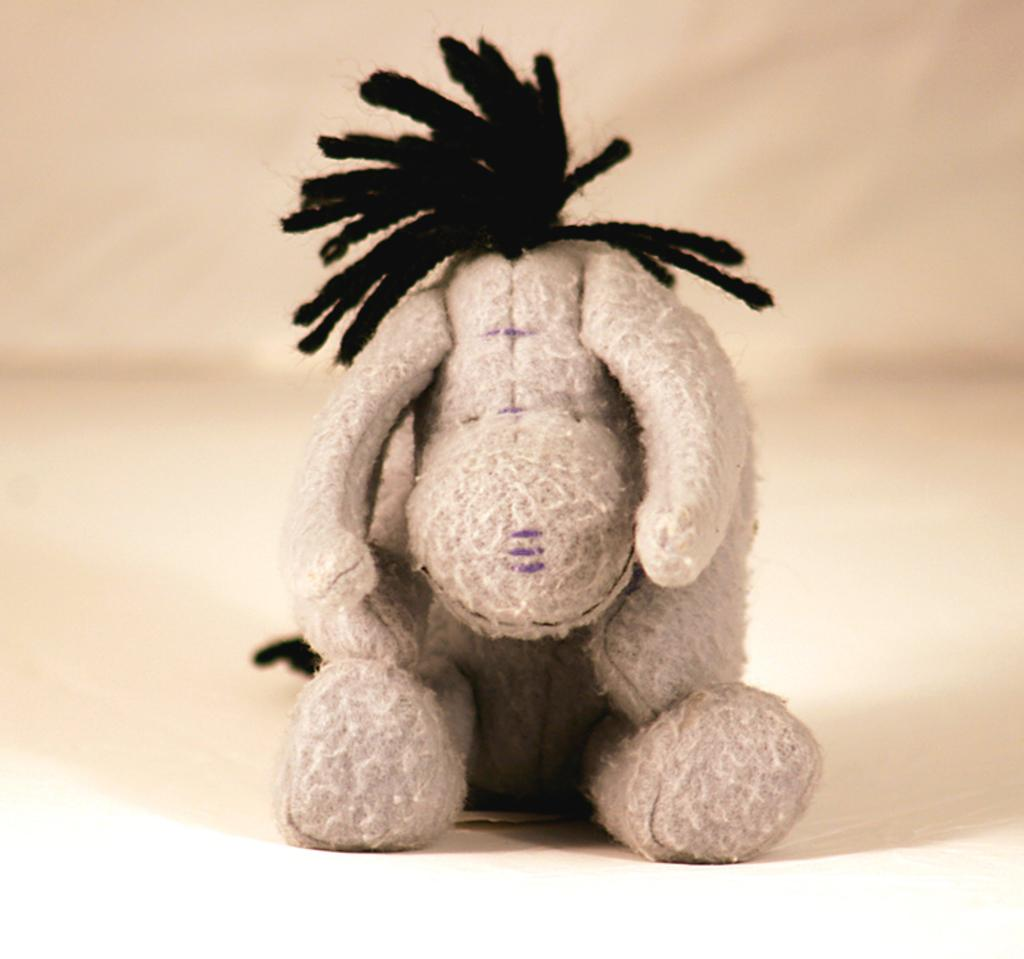What is placed on the floor in the image? There is a doll placed on the floor. How many ants are crawling on the doll's eye in the image? There are no ants present in the image, and therefore no such activity can be observed. 